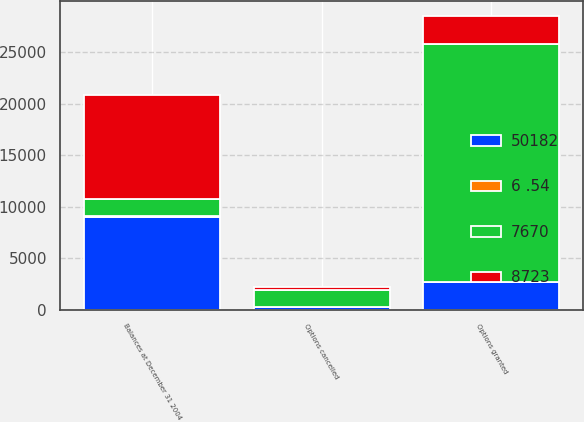Convert chart to OTSL. <chart><loc_0><loc_0><loc_500><loc_500><stacked_bar_chart><ecel><fcel>Options granted<fcel>Options cancelled<fcel>Balances at December 31 2004<nl><fcel>8723<fcel>2720<fcel>244<fcel>10112<nl><fcel>50182<fcel>2720<fcel>244<fcel>9050<nl><fcel>6 .54<fcel>8.48<fcel>6.88<fcel>10.35<nl><fcel>7670<fcel>23062<fcel>1677<fcel>1677<nl></chart> 